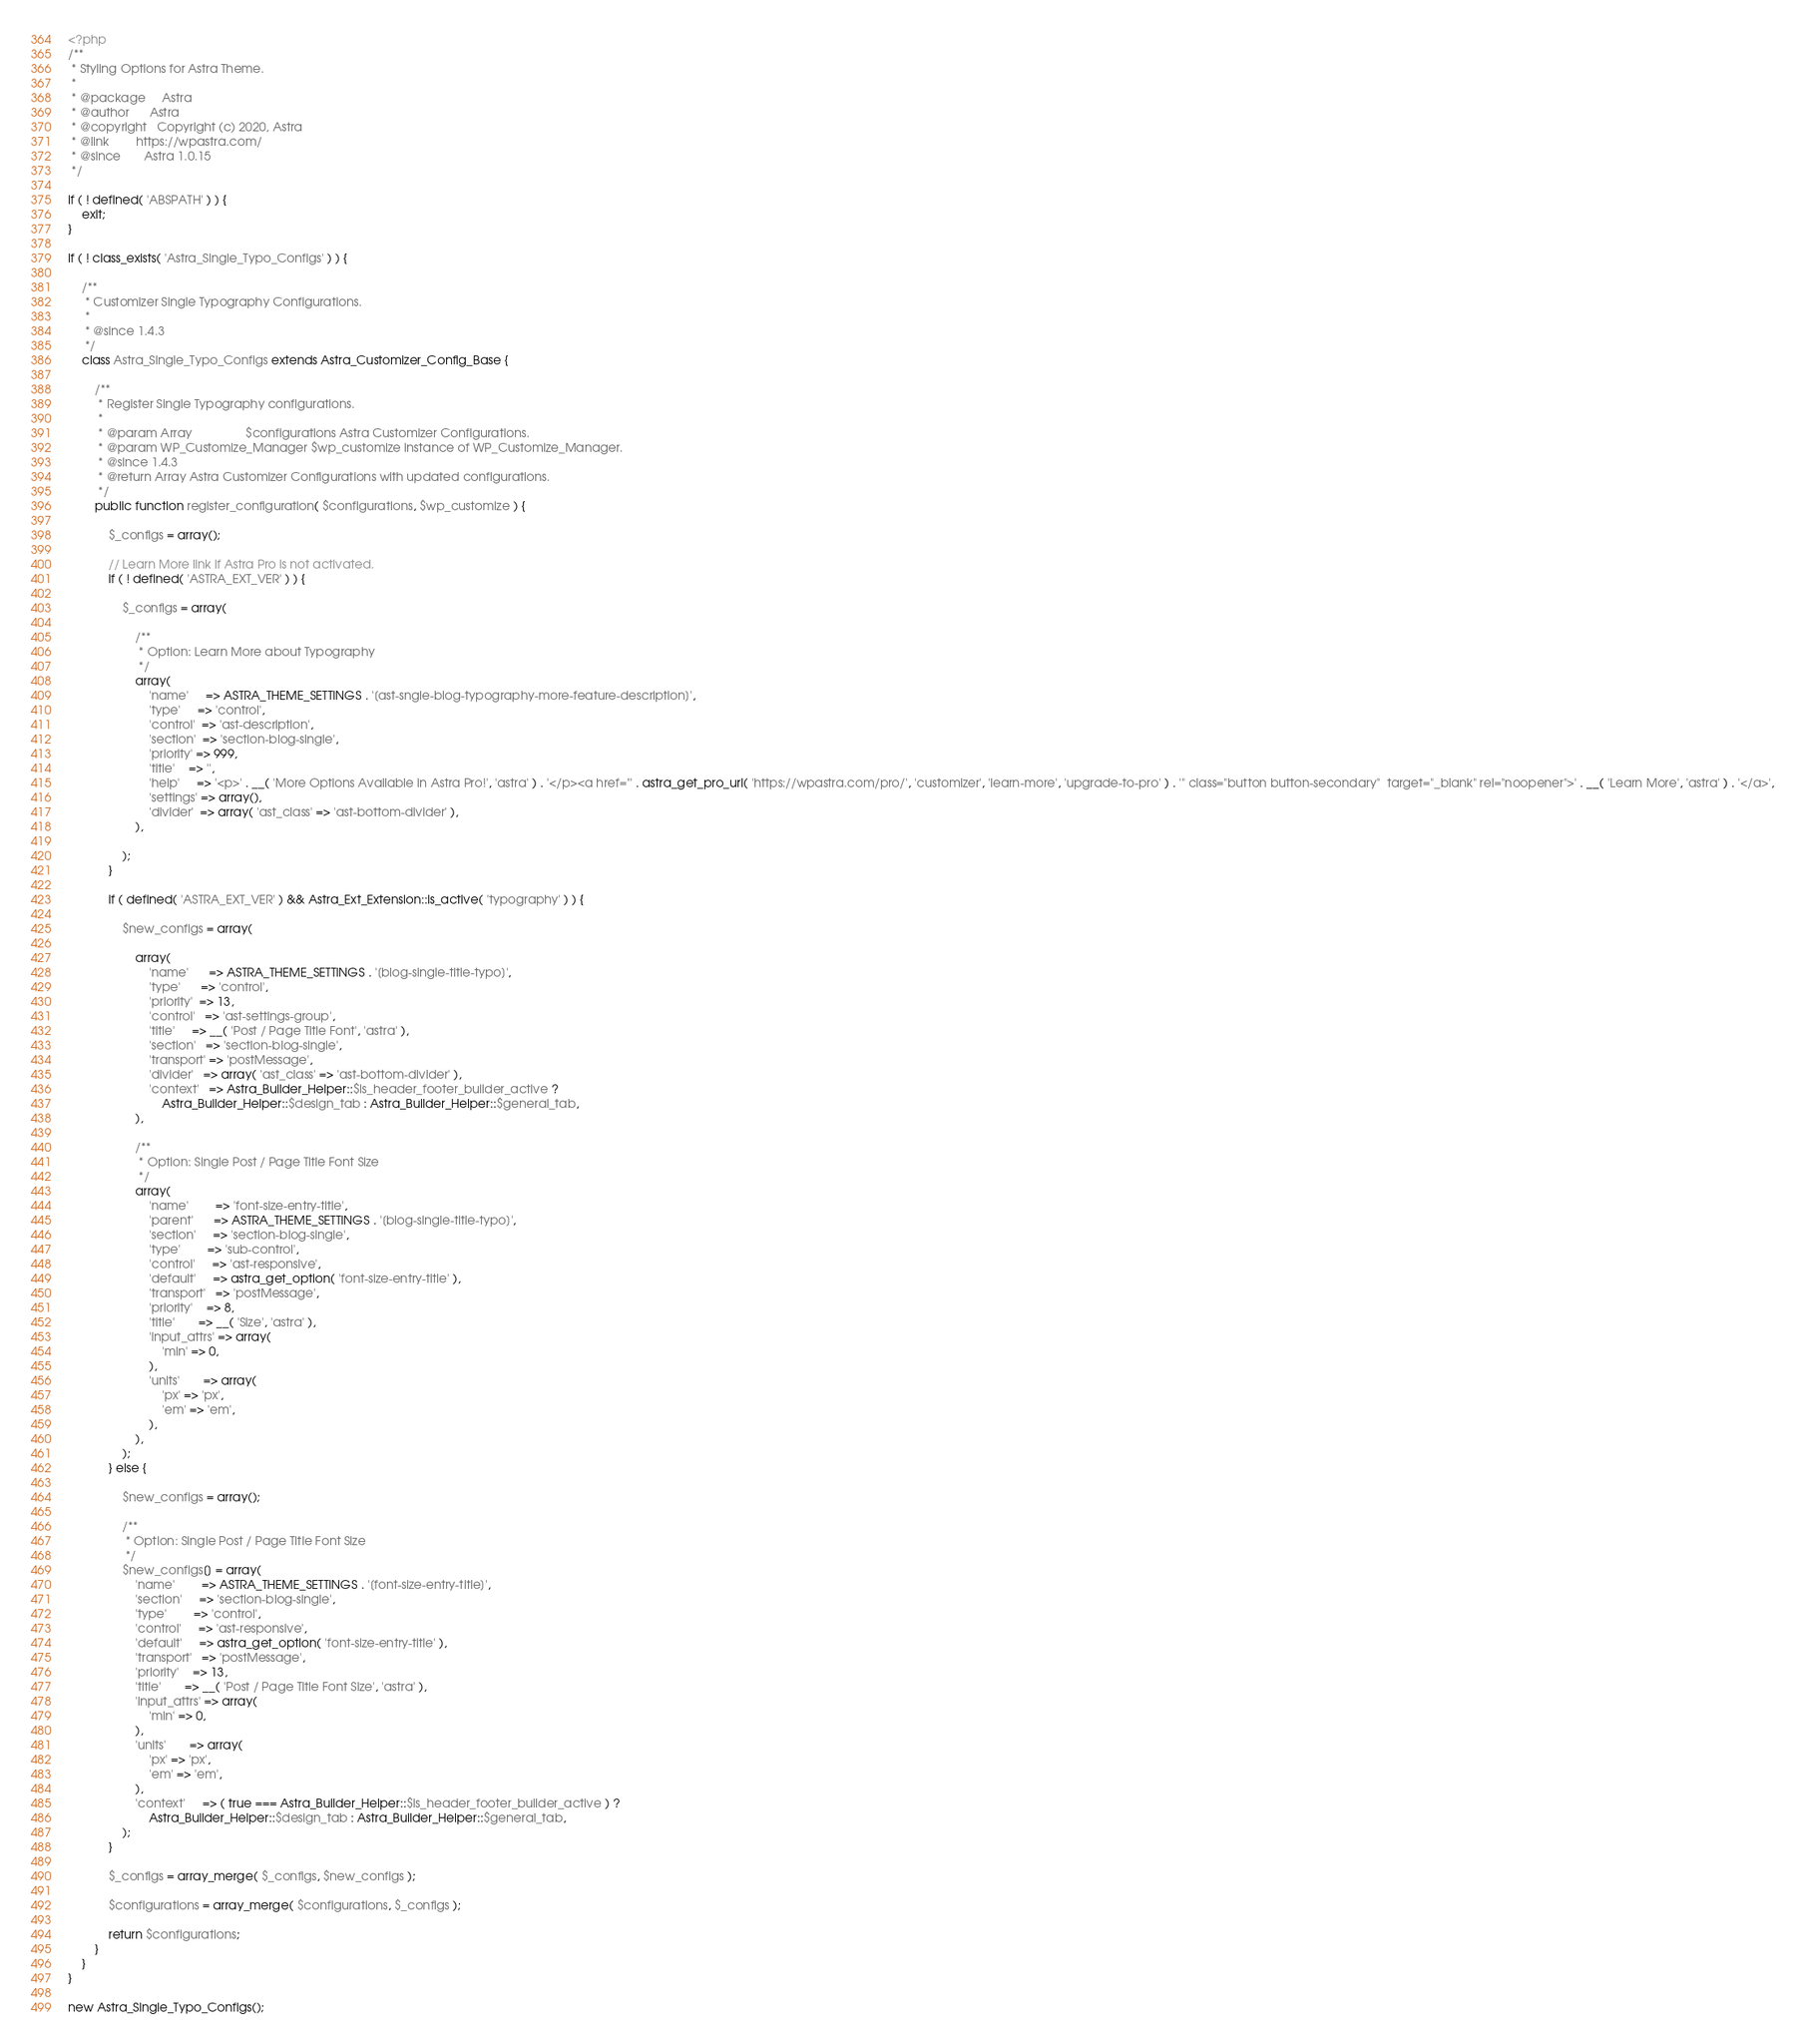Convert code to text. <code><loc_0><loc_0><loc_500><loc_500><_PHP_><?php
/**
 * Styling Options for Astra Theme.
 *
 * @package     Astra
 * @author      Astra
 * @copyright   Copyright (c) 2020, Astra
 * @link        https://wpastra.com/
 * @since       Astra 1.0.15
 */

if ( ! defined( 'ABSPATH' ) ) {
	exit;
}

if ( ! class_exists( 'Astra_Single_Typo_Configs' ) ) {

	/**
	 * Customizer Single Typography Configurations.
	 *
	 * @since 1.4.3
	 */
	class Astra_Single_Typo_Configs extends Astra_Customizer_Config_Base {

		/**
		 * Register Single Typography configurations.
		 *
		 * @param Array                $configurations Astra Customizer Configurations.
		 * @param WP_Customize_Manager $wp_customize instance of WP_Customize_Manager.
		 * @since 1.4.3
		 * @return Array Astra Customizer Configurations with updated configurations.
		 */
		public function register_configuration( $configurations, $wp_customize ) {

			$_configs = array();

			// Learn More link if Astra Pro is not activated.
			if ( ! defined( 'ASTRA_EXT_VER' ) ) {

				$_configs = array(

					/**
					 * Option: Learn More about Typography
					 */
					array(
						'name'     => ASTRA_THEME_SETTINGS . '[ast-sngle-blog-typography-more-feature-description]',
						'type'     => 'control',
						'control'  => 'ast-description',
						'section'  => 'section-blog-single',
						'priority' => 999,
						'title'    => '',
						'help'     => '<p>' . __( 'More Options Available in Astra Pro!', 'astra' ) . '</p><a href="' . astra_get_pro_url( 'https://wpastra.com/pro/', 'customizer', 'learn-more', 'upgrade-to-pro' ) . '" class="button button-secondary"  target="_blank" rel="noopener">' . __( 'Learn More', 'astra' ) . '</a>',
						'settings' => array(),
						'divider'  => array( 'ast_class' => 'ast-bottom-divider' ),
					),

				);
			}

			if ( defined( 'ASTRA_EXT_VER' ) && Astra_Ext_Extension::is_active( 'typography' ) ) {

				$new_configs = array(

					array(
						'name'      => ASTRA_THEME_SETTINGS . '[blog-single-title-typo]',
						'type'      => 'control',
						'priority'  => 13,
						'control'   => 'ast-settings-group',
						'title'     => __( 'Post / Page Title Font', 'astra' ),
						'section'   => 'section-blog-single',
						'transport' => 'postMessage',
						'divider'   => array( 'ast_class' => 'ast-bottom-divider' ),
						'context'   => Astra_Builder_Helper::$is_header_footer_builder_active ?
							Astra_Builder_Helper::$design_tab : Astra_Builder_Helper::$general_tab,
					),

					/**
					 * Option: Single Post / Page Title Font Size
					 */
					array(
						'name'        => 'font-size-entry-title',
						'parent'      => ASTRA_THEME_SETTINGS . '[blog-single-title-typo]',
						'section'     => 'section-blog-single',
						'type'        => 'sub-control',
						'control'     => 'ast-responsive',
						'default'     => astra_get_option( 'font-size-entry-title' ),
						'transport'   => 'postMessage',
						'priority'    => 8,
						'title'       => __( 'Size', 'astra' ),
						'input_attrs' => array(
							'min' => 0,
						),
						'units'       => array(
							'px' => 'px',
							'em' => 'em',
						),
					),
				);
			} else {

				$new_configs = array();

				/**
				 * Option: Single Post / Page Title Font Size
				 */
				$new_configs[] = array(
					'name'        => ASTRA_THEME_SETTINGS . '[font-size-entry-title]',
					'section'     => 'section-blog-single',
					'type'        => 'control',
					'control'     => 'ast-responsive',
					'default'     => astra_get_option( 'font-size-entry-title' ),
					'transport'   => 'postMessage',
					'priority'    => 13,
					'title'       => __( 'Post / Page Title Font Size', 'astra' ),
					'input_attrs' => array(
						'min' => 0,
					),
					'units'       => array(
						'px' => 'px',
						'em' => 'em',
					),
					'context'     => ( true === Astra_Builder_Helper::$is_header_footer_builder_active ) ?
						Astra_Builder_Helper::$design_tab : Astra_Builder_Helper::$general_tab,
				);
			}

			$_configs = array_merge( $_configs, $new_configs );

			$configurations = array_merge( $configurations, $_configs );

			return $configurations;
		}
	}
}

new Astra_Single_Typo_Configs();
</code> 